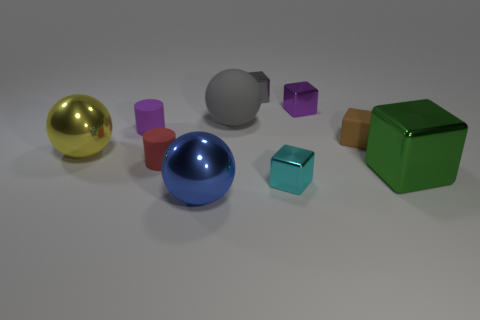How many small purple cubes are made of the same material as the gray ball?
Make the answer very short. 0. What is the shape of the small metallic object that is the same color as the big matte object?
Your answer should be very brief. Cube. There is a big shiny thing that is behind the large metallic cube; does it have the same shape as the big gray matte object?
Give a very brief answer. Yes. There is a block that is the same material as the big gray object; what is its color?
Provide a short and direct response. Brown. Is there a ball that is behind the cube in front of the large object right of the tiny matte block?
Give a very brief answer. Yes. What is the shape of the large yellow thing?
Offer a very short reply. Sphere. Is the number of large rubber objects that are to the left of the big green metal thing less than the number of red shiny cubes?
Provide a succinct answer. No. Are there any large metallic objects of the same shape as the tiny gray metallic thing?
Give a very brief answer. Yes. There is a gray metallic thing that is the same size as the brown thing; what shape is it?
Give a very brief answer. Cube. What number of objects are large metal things or large purple metal things?
Your answer should be very brief. 3. 